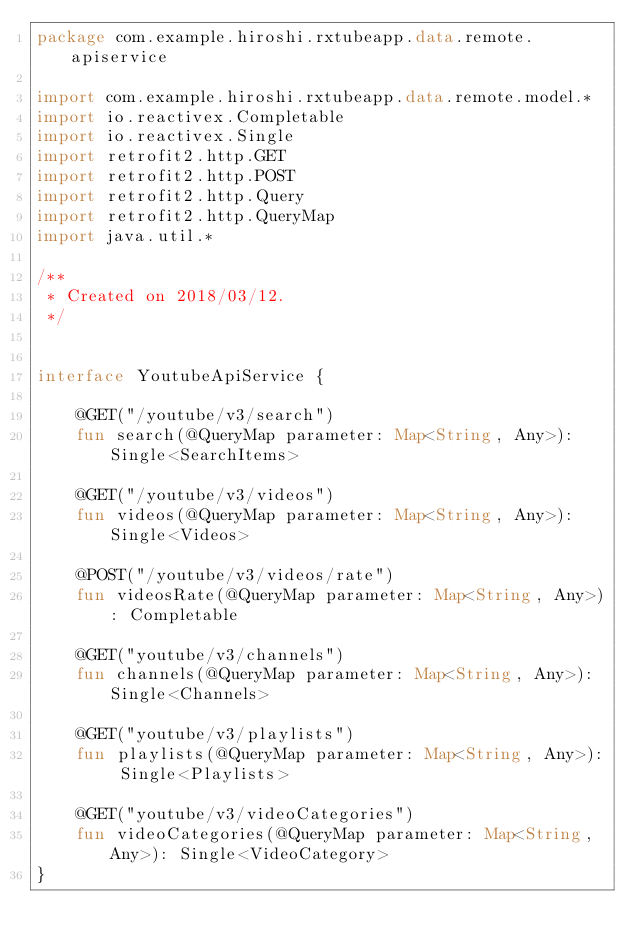Convert code to text. <code><loc_0><loc_0><loc_500><loc_500><_Kotlin_>package com.example.hiroshi.rxtubeapp.data.remote.apiservice

import com.example.hiroshi.rxtubeapp.data.remote.model.*
import io.reactivex.Completable
import io.reactivex.Single
import retrofit2.http.GET
import retrofit2.http.POST
import retrofit2.http.Query
import retrofit2.http.QueryMap
import java.util.*

/**
 * Created on 2018/03/12.
 */


interface YoutubeApiService {

    @GET("/youtube/v3/search")
    fun search(@QueryMap parameter: Map<String, Any>): Single<SearchItems>

    @GET("/youtube/v3/videos")
    fun videos(@QueryMap parameter: Map<String, Any>): Single<Videos>

    @POST("/youtube/v3/videos/rate")
    fun videosRate(@QueryMap parameter: Map<String, Any>): Completable

    @GET("youtube/v3/channels")
    fun channels(@QueryMap parameter: Map<String, Any>): Single<Channels>

    @GET("youtube/v3/playlists")
    fun playlists(@QueryMap parameter: Map<String, Any>): Single<Playlists>

    @GET("youtube/v3/videoCategories")
    fun videoCategories(@QueryMap parameter: Map<String, Any>): Single<VideoCategory>
}</code> 